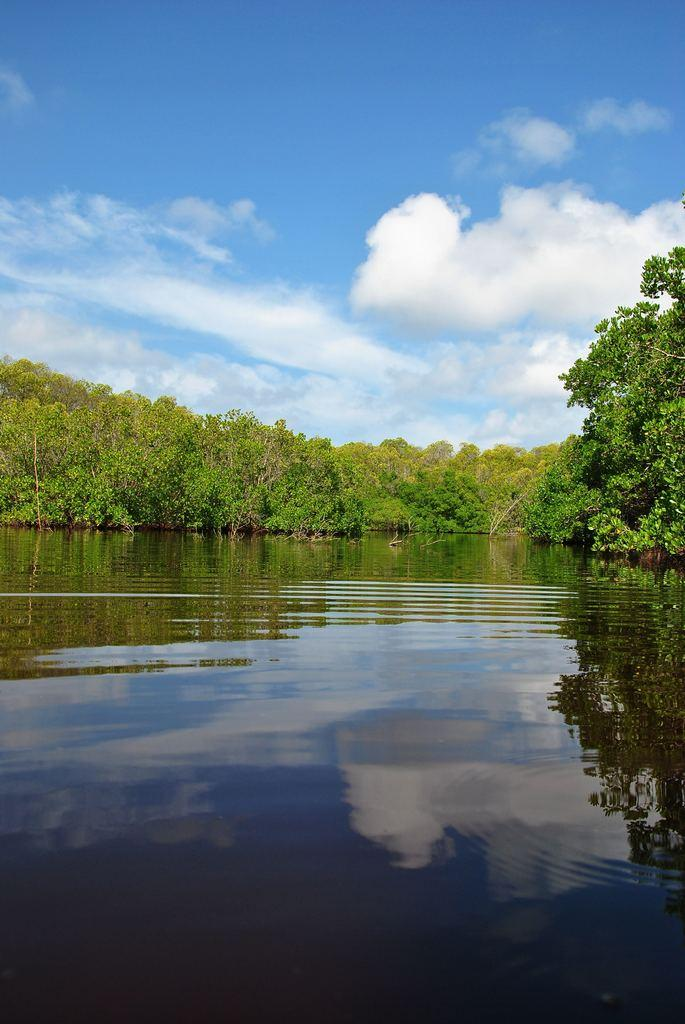What is visible in the foreground of the image? There is water in the foreground of the image. What can be seen in the background of the image? There is a group of trees in the background of the image. How would you describe the sky in the image? The sky is cloudy in the background of the image. What holiday is being celebrated in the image? There is no indication of a holiday being celebrated in the image. What is the cause of the cloudy sky in the image? The cause of the cloudy sky cannot be determined from the image alone. 